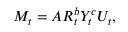<formula> <loc_0><loc_0><loc_500><loc_500>M _ { t } = A R _ { t } ^ { b } Y _ { t } ^ { c } U _ { t } ,</formula> 